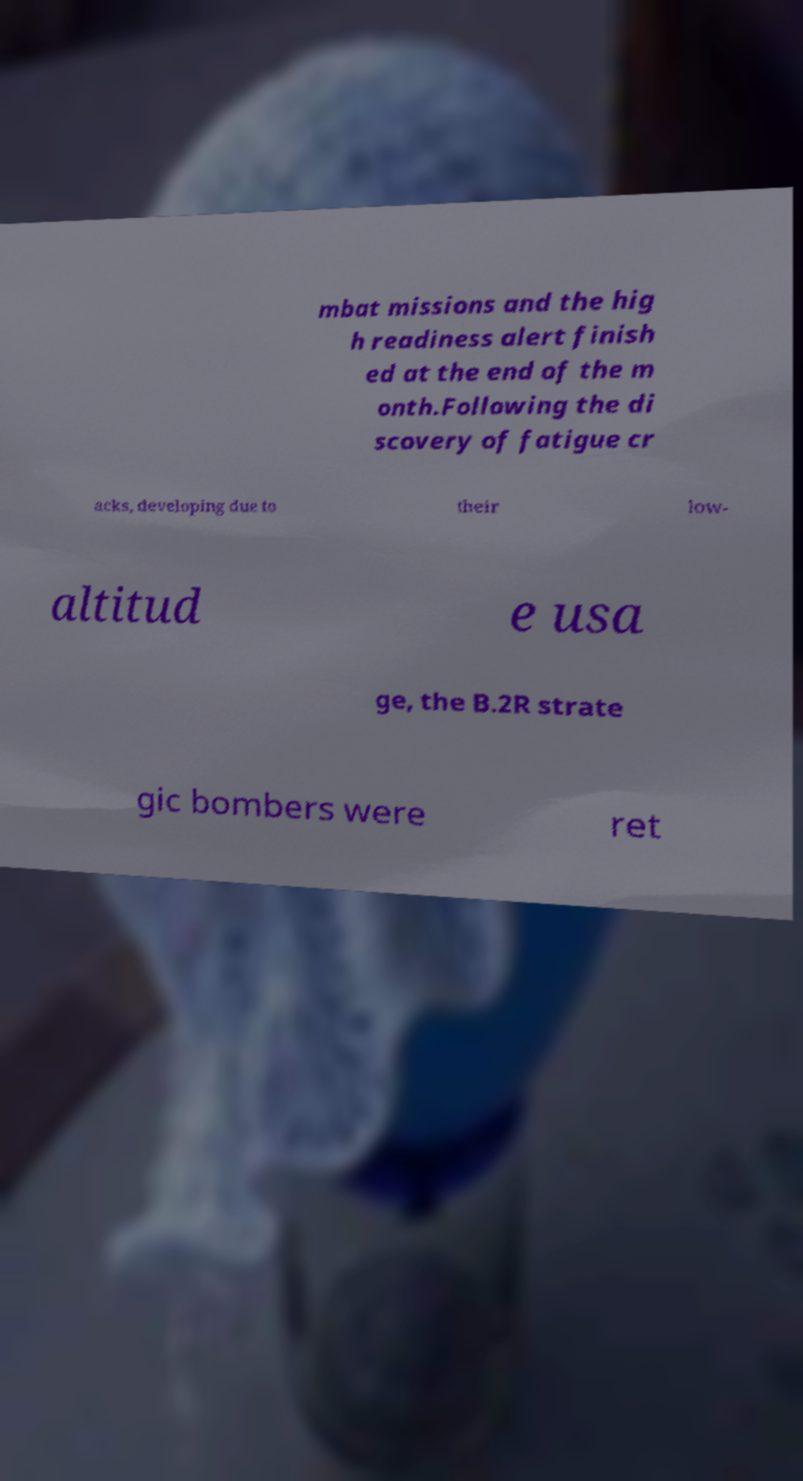For documentation purposes, I need the text within this image transcribed. Could you provide that? mbat missions and the hig h readiness alert finish ed at the end of the m onth.Following the di scovery of fatigue cr acks, developing due to their low- altitud e usa ge, the B.2R strate gic bombers were ret 